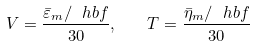<formula> <loc_0><loc_0><loc_500><loc_500>V = \frac { \bar { \varepsilon } _ { m } / \ h b { f } } { 3 0 } , \quad T = \frac { \bar { \eta } _ { m } / \ h b { f } } { 3 0 }</formula> 